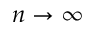Convert formula to latex. <formula><loc_0><loc_0><loc_500><loc_500>n \rightarrow \infty</formula> 